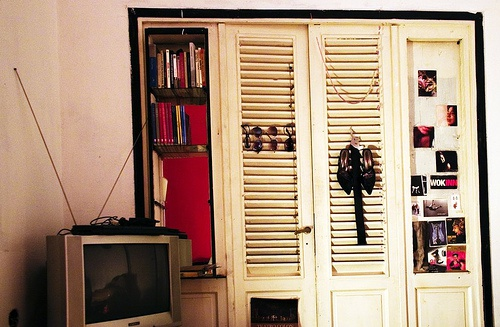Describe the objects in this image and their specific colors. I can see tv in tan, black, maroon, brown, and gray tones, book in tan, black, maroon, and brown tones, book in tan, black, maroon, brown, and orange tones, book in tan, maroon, black, and brown tones, and book in tan, brown, maroon, and black tones in this image. 